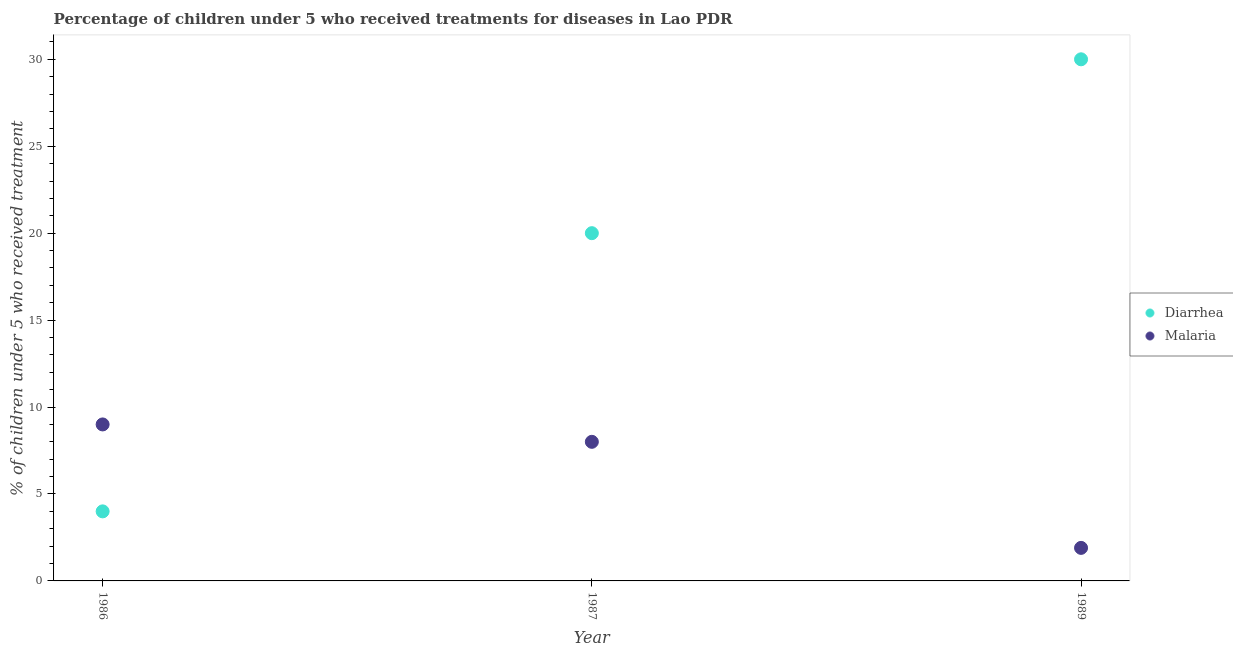Is the number of dotlines equal to the number of legend labels?
Make the answer very short. Yes. What is the percentage of children who received treatment for malaria in 1986?
Your answer should be very brief. 9. Across all years, what is the maximum percentage of children who received treatment for diarrhoea?
Provide a short and direct response. 30. Across all years, what is the minimum percentage of children who received treatment for malaria?
Offer a very short reply. 1.9. In which year was the percentage of children who received treatment for malaria maximum?
Ensure brevity in your answer.  1986. In which year was the percentage of children who received treatment for diarrhoea minimum?
Provide a succinct answer. 1986. What is the difference between the percentage of children who received treatment for diarrhoea in 1987 and that in 1989?
Your answer should be very brief. -10. What is the ratio of the percentage of children who received treatment for malaria in 1986 to that in 1989?
Make the answer very short. 4.74. Is the percentage of children who received treatment for diarrhoea in 1986 less than that in 1989?
Offer a terse response. Yes. Is the difference between the percentage of children who received treatment for diarrhoea in 1986 and 1989 greater than the difference between the percentage of children who received treatment for malaria in 1986 and 1989?
Keep it short and to the point. No. What is the difference between the highest and the lowest percentage of children who received treatment for diarrhoea?
Your answer should be compact. 26. In how many years, is the percentage of children who received treatment for diarrhoea greater than the average percentage of children who received treatment for diarrhoea taken over all years?
Your answer should be compact. 2. Is the sum of the percentage of children who received treatment for malaria in 1986 and 1987 greater than the maximum percentage of children who received treatment for diarrhoea across all years?
Your response must be concise. No. What is the difference between two consecutive major ticks on the Y-axis?
Make the answer very short. 5. Are the values on the major ticks of Y-axis written in scientific E-notation?
Your answer should be very brief. No. Does the graph contain any zero values?
Offer a terse response. No. Where does the legend appear in the graph?
Provide a succinct answer. Center right. How many legend labels are there?
Provide a short and direct response. 2. What is the title of the graph?
Your answer should be compact. Percentage of children under 5 who received treatments for diseases in Lao PDR. What is the label or title of the X-axis?
Offer a very short reply. Year. What is the label or title of the Y-axis?
Give a very brief answer. % of children under 5 who received treatment. What is the % of children under 5 who received treatment in Malaria in 1986?
Give a very brief answer. 9. What is the % of children under 5 who received treatment of Diarrhea in 1989?
Your response must be concise. 30. What is the % of children under 5 who received treatment of Malaria in 1989?
Keep it short and to the point. 1.9. What is the total % of children under 5 who received treatment in Malaria in the graph?
Ensure brevity in your answer.  18.9. What is the difference between the % of children under 5 who received treatment of Diarrhea in 1986 and that in 1987?
Ensure brevity in your answer.  -16. What is the difference between the % of children under 5 who received treatment of Diarrhea in 1986 and that in 1989?
Make the answer very short. -26. What is the difference between the % of children under 5 who received treatment of Malaria in 1986 and that in 1989?
Provide a short and direct response. 7.1. What is the difference between the % of children under 5 who received treatment of Diarrhea in 1986 and the % of children under 5 who received treatment of Malaria in 1989?
Make the answer very short. 2.1. What is the difference between the % of children under 5 who received treatment of Diarrhea in 1987 and the % of children under 5 who received treatment of Malaria in 1989?
Provide a short and direct response. 18.1. What is the average % of children under 5 who received treatment in Diarrhea per year?
Your answer should be compact. 18. In the year 1987, what is the difference between the % of children under 5 who received treatment in Diarrhea and % of children under 5 who received treatment in Malaria?
Give a very brief answer. 12. In the year 1989, what is the difference between the % of children under 5 who received treatment in Diarrhea and % of children under 5 who received treatment in Malaria?
Ensure brevity in your answer.  28.1. What is the ratio of the % of children under 5 who received treatment of Diarrhea in 1986 to that in 1989?
Offer a very short reply. 0.13. What is the ratio of the % of children under 5 who received treatment in Malaria in 1986 to that in 1989?
Keep it short and to the point. 4.74. What is the ratio of the % of children under 5 who received treatment in Malaria in 1987 to that in 1989?
Provide a succinct answer. 4.21. What is the difference between the highest and the second highest % of children under 5 who received treatment of Malaria?
Your answer should be compact. 1. 